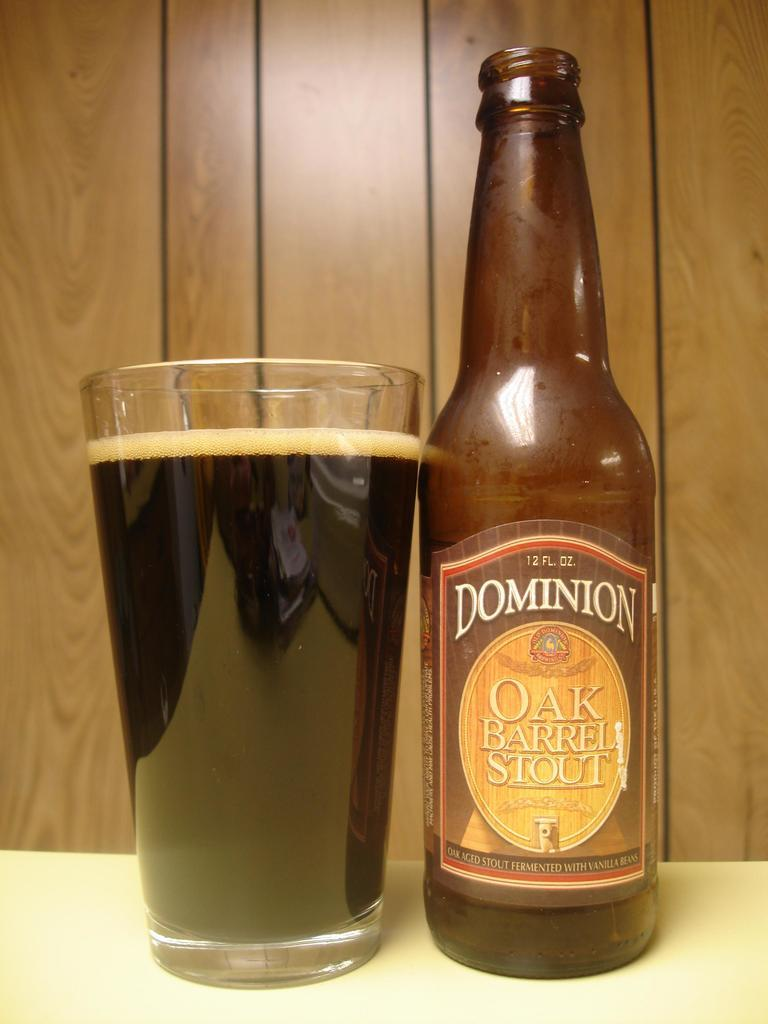<image>
Relay a brief, clear account of the picture shown. A bottle of Dominion Oak Barrel Stout next to a glass. 